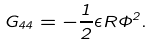<formula> <loc_0><loc_0><loc_500><loc_500>G _ { 4 4 } = - \frac { 1 } { 2 } \epsilon R \Phi ^ { 2 } .</formula> 